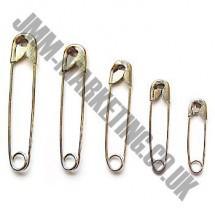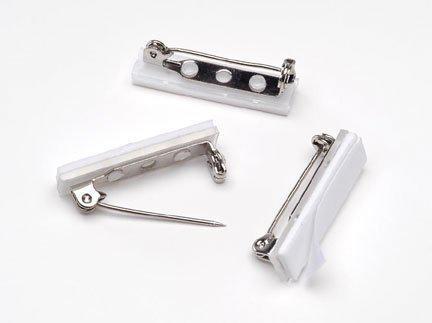The first image is the image on the left, the second image is the image on the right. For the images shown, is this caption "There are more pins shown in the image on the left." true? Answer yes or no. Yes. 